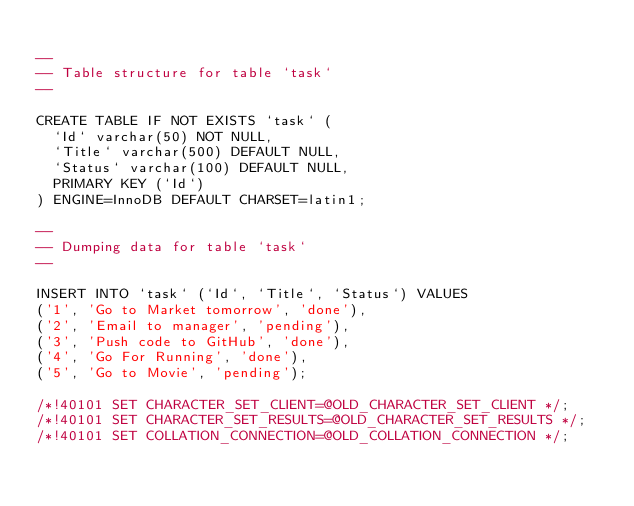<code> <loc_0><loc_0><loc_500><loc_500><_SQL_>
--
-- Table structure for table `task`
--

CREATE TABLE IF NOT EXISTS `task` (
  `Id` varchar(50) NOT NULL,
  `Title` varchar(500) DEFAULT NULL,
  `Status` varchar(100) DEFAULT NULL,
  PRIMARY KEY (`Id`)
) ENGINE=InnoDB DEFAULT CHARSET=latin1;

--
-- Dumping data for table `task`
--

INSERT INTO `task` (`Id`, `Title`, `Status`) VALUES
('1', 'Go to Market tomorrow', 'done'),
('2', 'Email to manager', 'pending'),
('3', 'Push code to GitHub', 'done'),
('4', 'Go For Running', 'done'),
('5', 'Go to Movie', 'pending');

/*!40101 SET CHARACTER_SET_CLIENT=@OLD_CHARACTER_SET_CLIENT */;
/*!40101 SET CHARACTER_SET_RESULTS=@OLD_CHARACTER_SET_RESULTS */;
/*!40101 SET COLLATION_CONNECTION=@OLD_COLLATION_CONNECTION */;
</code> 